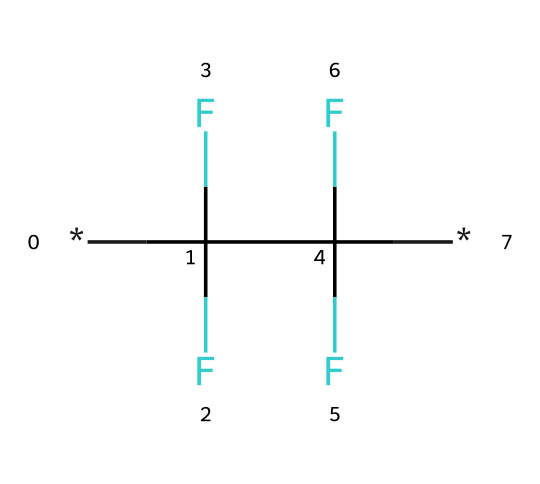how many carbon atoms are in this structure? The SMILES representation indicates that there are two occurrences of the repeating unit C, which signifies there are two carbon atoms present in the structure.
Answer: two how many fluorine atoms are present in the molecule? The structure contains three instances of the F atom attached to each carbon. Since there are two carbon atoms, that leads to a total of six fluorine atoms in this compound.
Answer: six what is the general chemical class of this compound? The presence of multiple fluorine atoms and carbon suggests this compound is a fluoropolymer, commonly used in non-stick coatings.
Answer: fluoropolymer which property does the high fluorine content impart to this coating? The high fluorine content generally enhances the chemical resistance, thermal stability, and non-stick properties, making it ideal for cookware applications.
Answer: non-stick what type of bond predominates in this structure? The structure showcases carbon-fluorine single bonds, which are strong and stable due to the electronegativity of fluorine and its ability to form bonds with carbon.
Answer: single bond why might this compound be used for non-stick surfaces? The chemical structure provides a low surface energy due to the high fluorine content, leading to reduced adhesion of food, making it effective for non-stick applications.
Answer: low adhesion 